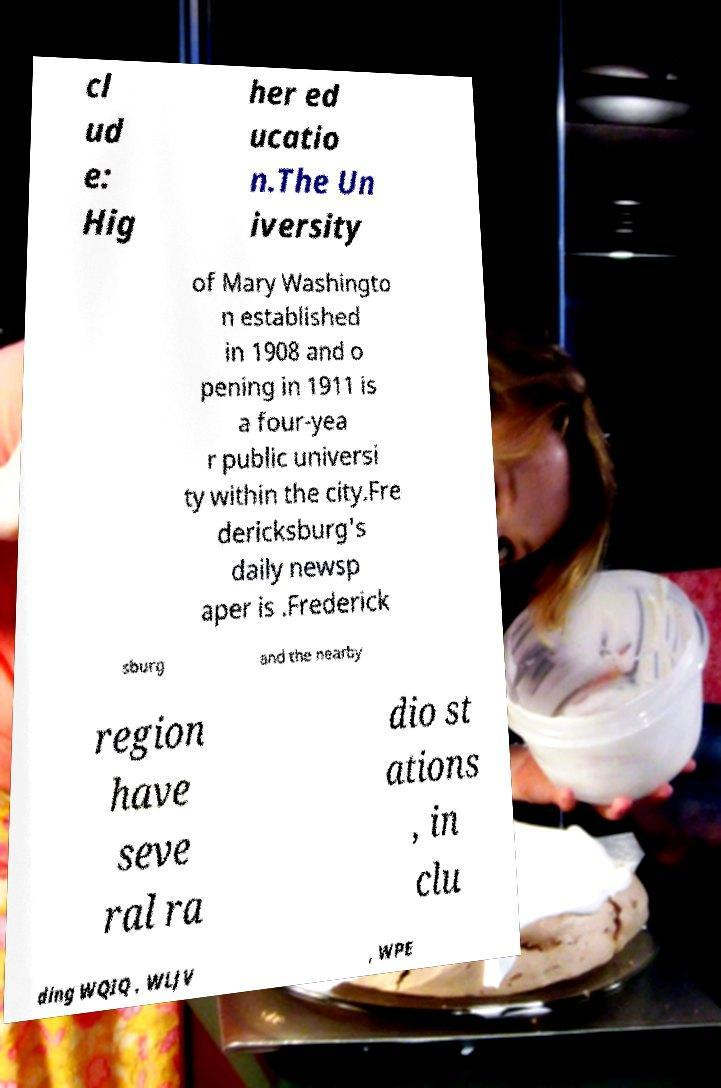For documentation purposes, I need the text within this image transcribed. Could you provide that? cl ud e: Hig her ed ucatio n.The Un iversity of Mary Washingto n established in 1908 and o pening in 1911 is a four-yea r public universi ty within the city.Fre dericksburg's daily newsp aper is .Frederick sburg and the nearby region have seve ral ra dio st ations , in clu ding WQIQ , WLJV , WPE 